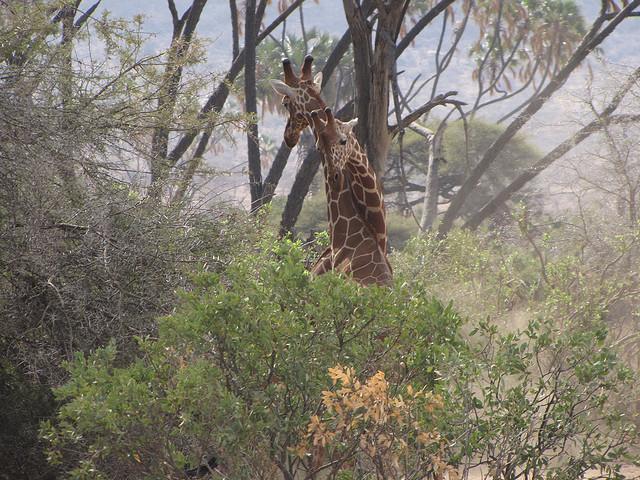How many giraffes are leaning towards the trees?
Give a very brief answer. 2. How many giraffes are there?
Give a very brief answer. 2. 